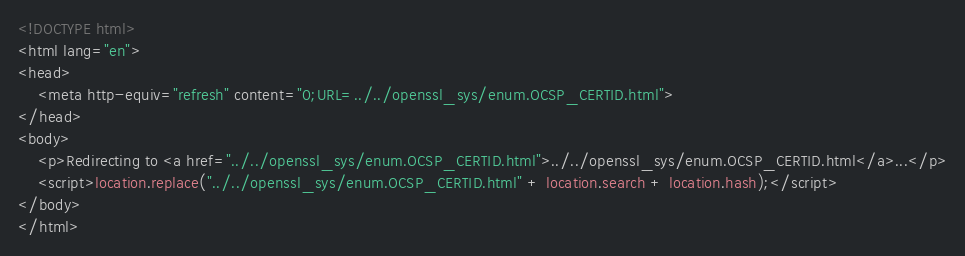Convert code to text. <code><loc_0><loc_0><loc_500><loc_500><_HTML_><!DOCTYPE html>
<html lang="en">
<head>
    <meta http-equiv="refresh" content="0;URL=../../openssl_sys/enum.OCSP_CERTID.html">
</head>
<body>
    <p>Redirecting to <a href="../../openssl_sys/enum.OCSP_CERTID.html">../../openssl_sys/enum.OCSP_CERTID.html</a>...</p>
    <script>location.replace("../../openssl_sys/enum.OCSP_CERTID.html" + location.search + location.hash);</script>
</body>
</html></code> 